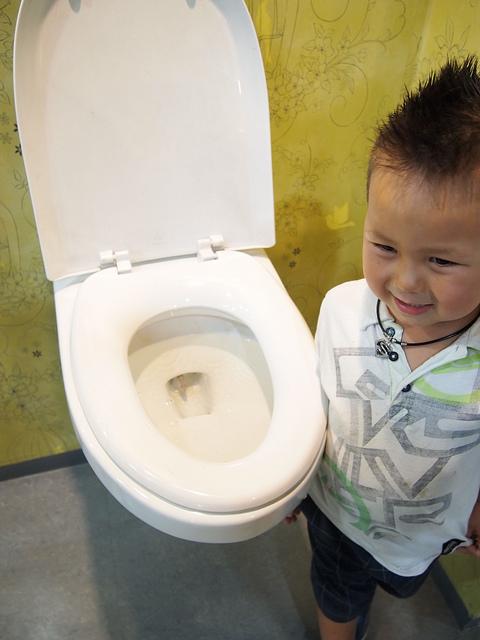Does this child like the toilet?
Write a very short answer. Yes. What room is this?
Short answer required. Bathroom. What is the white object?
Write a very short answer. Toilet. 